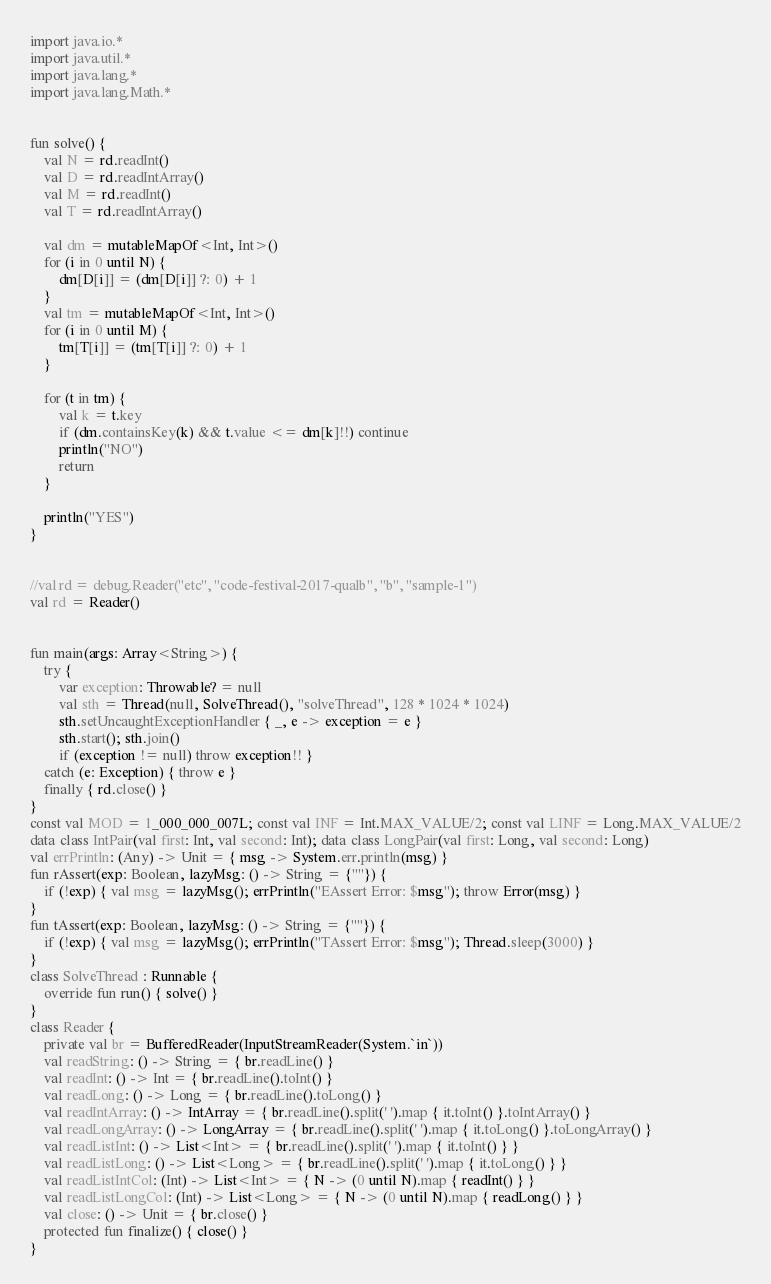<code> <loc_0><loc_0><loc_500><loc_500><_Kotlin_>import java.io.*
import java.util.*
import java.lang.*
import java.lang.Math.*


fun solve() {
    val N = rd.readInt()
    val D = rd.readIntArray()
    val M = rd.readInt()
    val T = rd.readIntArray()

    val dm = mutableMapOf<Int, Int>()
    for (i in 0 until N) {
        dm[D[i]] = (dm[D[i]] ?: 0) + 1
    }
    val tm = mutableMapOf<Int, Int>()
    for (i in 0 until M) {
        tm[T[i]] = (tm[T[i]] ?: 0) + 1
    }

    for (t in tm) {
        val k = t.key
        if (dm.containsKey(k) && t.value <= dm[k]!!) continue
        println("NO")
        return
    }

    println("YES")
}


//val rd = debug.Reader("etc", "code-festival-2017-qualb", "b", "sample-1")
val rd = Reader()


fun main(args: Array<String>) {
    try {
        var exception: Throwable? = null
        val sth = Thread(null, SolveThread(), "solveThread", 128 * 1024 * 1024)
        sth.setUncaughtExceptionHandler { _, e -> exception = e }
        sth.start(); sth.join()
        if (exception != null) throw exception!! }
    catch (e: Exception) { throw e }
    finally { rd.close() }
}
const val MOD = 1_000_000_007L; const val INF = Int.MAX_VALUE/2; const val LINF = Long.MAX_VALUE/2
data class IntPair(val first: Int, val second: Int); data class LongPair(val first: Long, val second: Long)
val errPrintln: (Any) -> Unit = { msg -> System.err.println(msg) }
fun rAssert(exp: Boolean, lazyMsg: () -> String = {""}) {
    if (!exp) { val msg = lazyMsg(); errPrintln("EAssert Error: $msg"); throw Error(msg) }
}
fun tAssert(exp: Boolean, lazyMsg: () -> String = {""}) {
    if (!exp) { val msg = lazyMsg(); errPrintln("TAssert Error: $msg"); Thread.sleep(3000) }
}
class SolveThread : Runnable {
    override fun run() { solve() }
}
class Reader {
    private val br = BufferedReader(InputStreamReader(System.`in`))
    val readString: () -> String = { br.readLine() }
    val readInt: () -> Int = { br.readLine().toInt() }
    val readLong: () -> Long = { br.readLine().toLong() }
    val readIntArray: () -> IntArray = { br.readLine().split(' ').map { it.toInt() }.toIntArray() }
    val readLongArray: () -> LongArray = { br.readLine().split(' ').map { it.toLong() }.toLongArray() }
    val readListInt: () -> List<Int> = { br.readLine().split(' ').map { it.toInt() } }
    val readListLong: () -> List<Long> = { br.readLine().split(' ').map { it.toLong() } }
    val readListIntCol: (Int) -> List<Int> = { N -> (0 until N).map { readInt() } }
    val readListLongCol: (Int) -> List<Long> = { N -> (0 until N).map { readLong() } }
    val close: () -> Unit = { br.close() }
    protected fun finalize() { close() }
}
</code> 